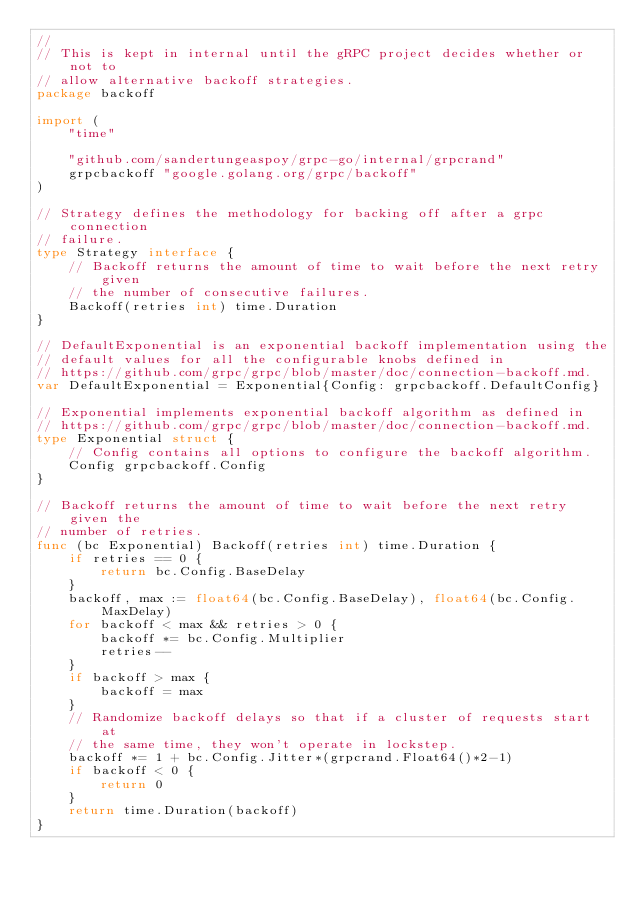Convert code to text. <code><loc_0><loc_0><loc_500><loc_500><_Go_>//
// This is kept in internal until the gRPC project decides whether or not to
// allow alternative backoff strategies.
package backoff

import (
	"time"

	"github.com/sandertungeaspoy/grpc-go/internal/grpcrand"
	grpcbackoff "google.golang.org/grpc/backoff"
)

// Strategy defines the methodology for backing off after a grpc connection
// failure.
type Strategy interface {
	// Backoff returns the amount of time to wait before the next retry given
	// the number of consecutive failures.
	Backoff(retries int) time.Duration
}

// DefaultExponential is an exponential backoff implementation using the
// default values for all the configurable knobs defined in
// https://github.com/grpc/grpc/blob/master/doc/connection-backoff.md.
var DefaultExponential = Exponential{Config: grpcbackoff.DefaultConfig}

// Exponential implements exponential backoff algorithm as defined in
// https://github.com/grpc/grpc/blob/master/doc/connection-backoff.md.
type Exponential struct {
	// Config contains all options to configure the backoff algorithm.
	Config grpcbackoff.Config
}

// Backoff returns the amount of time to wait before the next retry given the
// number of retries.
func (bc Exponential) Backoff(retries int) time.Duration {
	if retries == 0 {
		return bc.Config.BaseDelay
	}
	backoff, max := float64(bc.Config.BaseDelay), float64(bc.Config.MaxDelay)
	for backoff < max && retries > 0 {
		backoff *= bc.Config.Multiplier
		retries--
	}
	if backoff > max {
		backoff = max
	}
	// Randomize backoff delays so that if a cluster of requests start at
	// the same time, they won't operate in lockstep.
	backoff *= 1 + bc.Config.Jitter*(grpcrand.Float64()*2-1)
	if backoff < 0 {
		return 0
	}
	return time.Duration(backoff)
}
</code> 